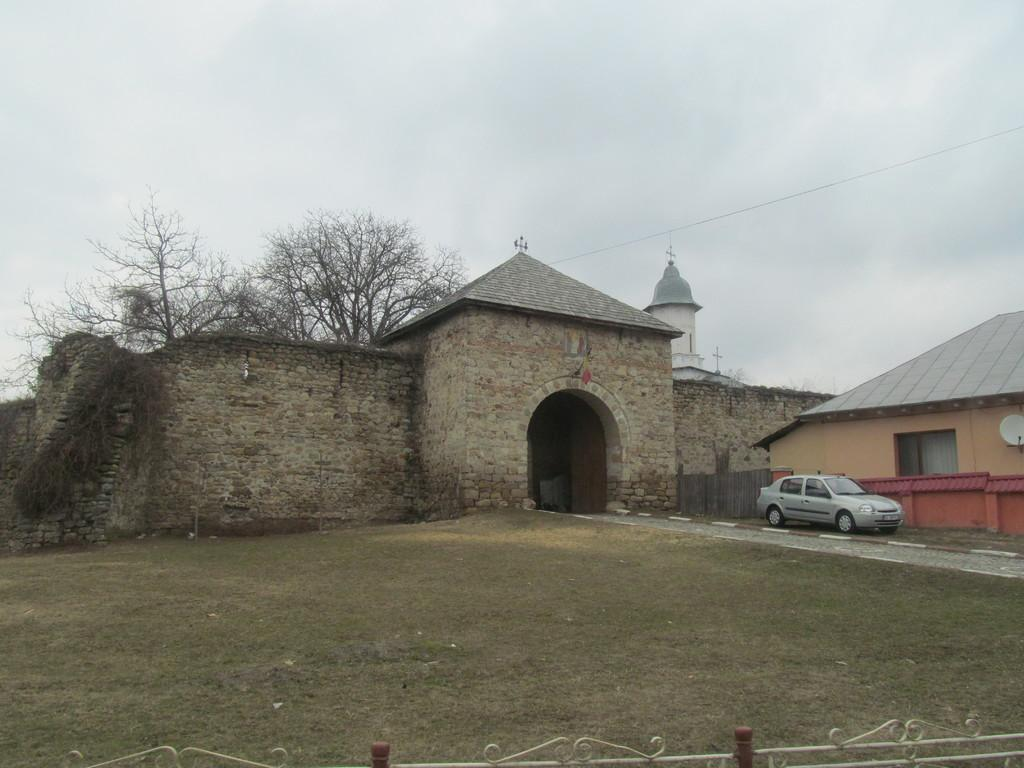What type of structures can be seen in the image? There are buildings in the image. What mode of transportation is visible on the road? There is a car on the road in the image. What architectural feature is present at the bottom of the image? Iron grilles are visible at the bottom of the image. What type of vegetation is present at the bottom of the image? Grass is present at the bottom of the image. What can be seen in the background of the image? There are trees and the sky visible in the background of the image. What color is the wool that the kitty is playing with in the image? There is no kitty or wool present in the image. What advice would you give to the daughter in the image? There is no daughter present in the image. 